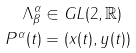<formula> <loc_0><loc_0><loc_500><loc_500>\Lambda ^ { \alpha } _ { \beta } & \in G L ( 2 , \mathbb { R } ) \\ P ^ { \alpha } ( t ) & = \left ( x ( t ) , y ( t ) \right )</formula> 